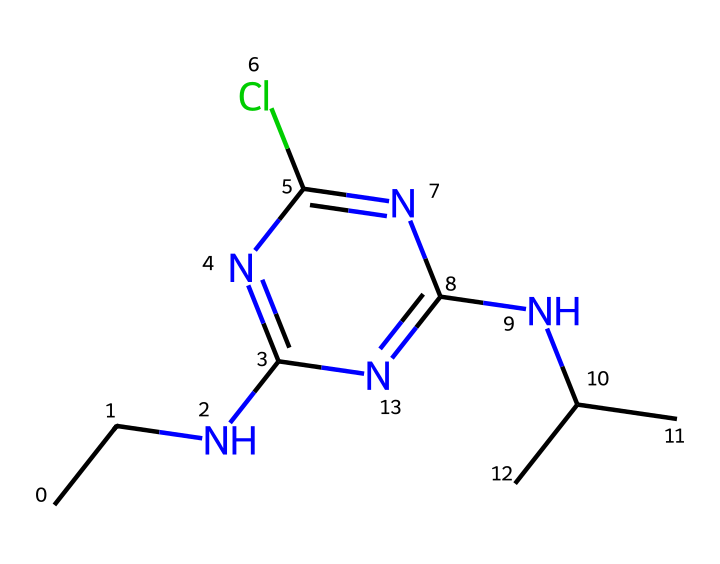What is the molecular formula of atrazine? The SMILES representation indicates the structure of atrazine. Counting the atoms present based on the SMILES, we find 10 carbons (C), 14 hydrogens (H), 4 nitrogens (N), and 1 chlorine (Cl). Thus, the molecular formula is C8H14ClN5.
Answer: C8H14ClN5 How many nitrogen atoms are in atrazine? By analyzing the SMILES representation, we can identify the nitrogen atoms present in the structure. There are five distinct nitrogen atoms as specified in the formula.
Answer: 5 Is atrazine a primary or secondary amine? The chemical structure shows a nitrogen atom bonded to two carbon atoms in one instance (NC(C)C), which characterizes it as a secondary amine. Therefore, atrazine contains secondary amines.
Answer: secondary What property might atrazine have that is concerning for water contamination? Atrazine's structure with multiple nitrogen atoms could suggest high solubility in water, which is a property that can lead to contamination in water sources.
Answer: high solubility What functional groups are present in atrazine? The SMILES representation includes amino groups as indicated by the nitrogen (N) atoms attached to carbon frameworks. This suggests that atrazine contains amine functional groups.
Answer: amine functional groups Which part of the atrazine structure contributes to its herbicidal activity? The presence of the chlorinated ring attached to nitrogens in the structure generally enhances the herbicidal activity of atrazine, making it effective against certain weeds.
Answer: chlorinated ring 